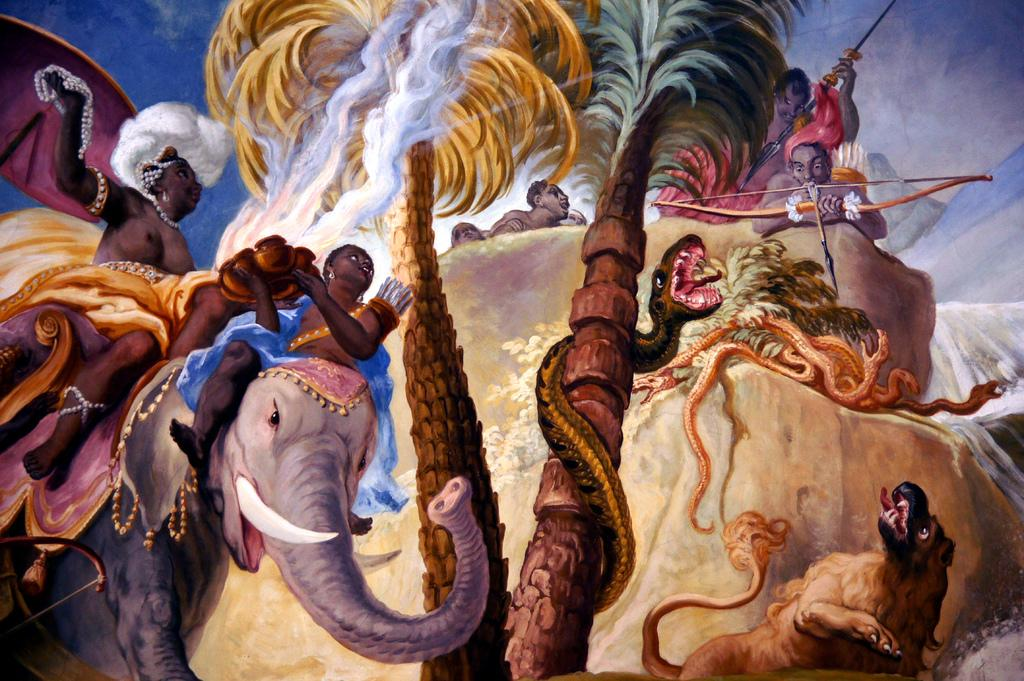What type of natural elements can be seen in the painting? The painting contains trees, mountains, water, and clouds. Are there any animals depicted in the painting? Yes, there is an elephant depicted in the painting. What other living beings are present in the painting? There are persons in the painting. What objects can be seen in the painting? Snakes, arrows, and an elephant are visible in the painting. What is visible in the sky in the painting? The sky is visible in the painting. What type of popcorn is being used as a weapon in the painting? There is no popcorn present in the painting, and therefore no such weapon can be observed. What is the opinion of the elephant about the snakes in the painting? The painting is a visual representation and does not convey opinions or thoughts of the depicted subjects. 